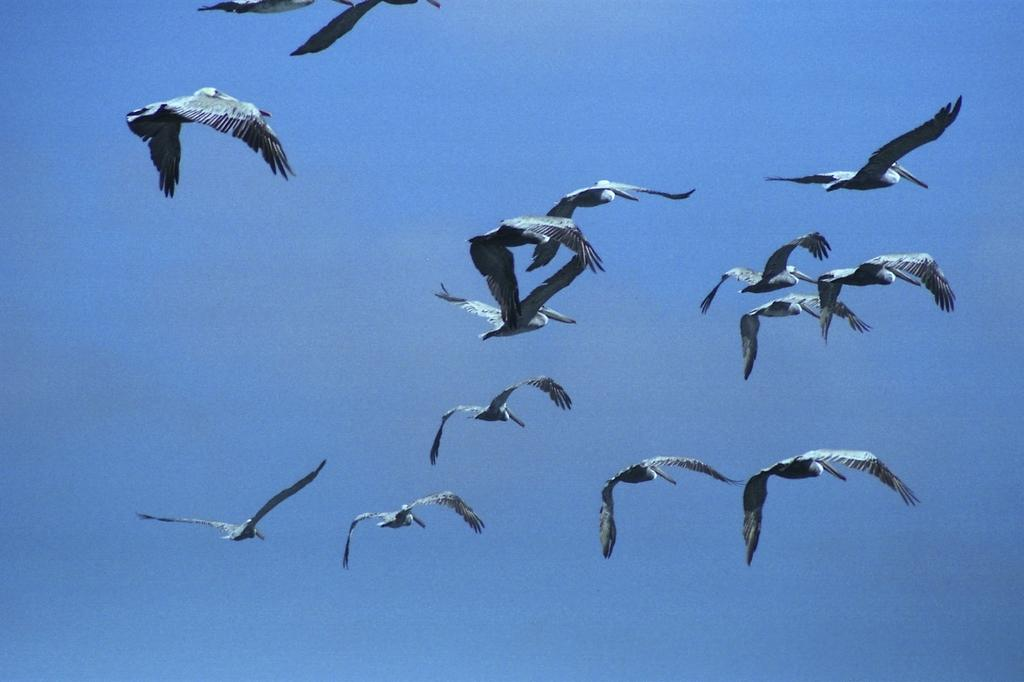What type of animals can be seen in the image? Birds can be seen in the image. What are the birds doing in the image? The birds are flying in the sky. What type of magic spell do the birds use to fly in the image? The birds do not use any magic spells to fly in the image; they are simply flying as birds naturally do. What type of underwear are the birds wearing in the image? There are no birds wearing underwear in the image, as birds do not wear clothing. 